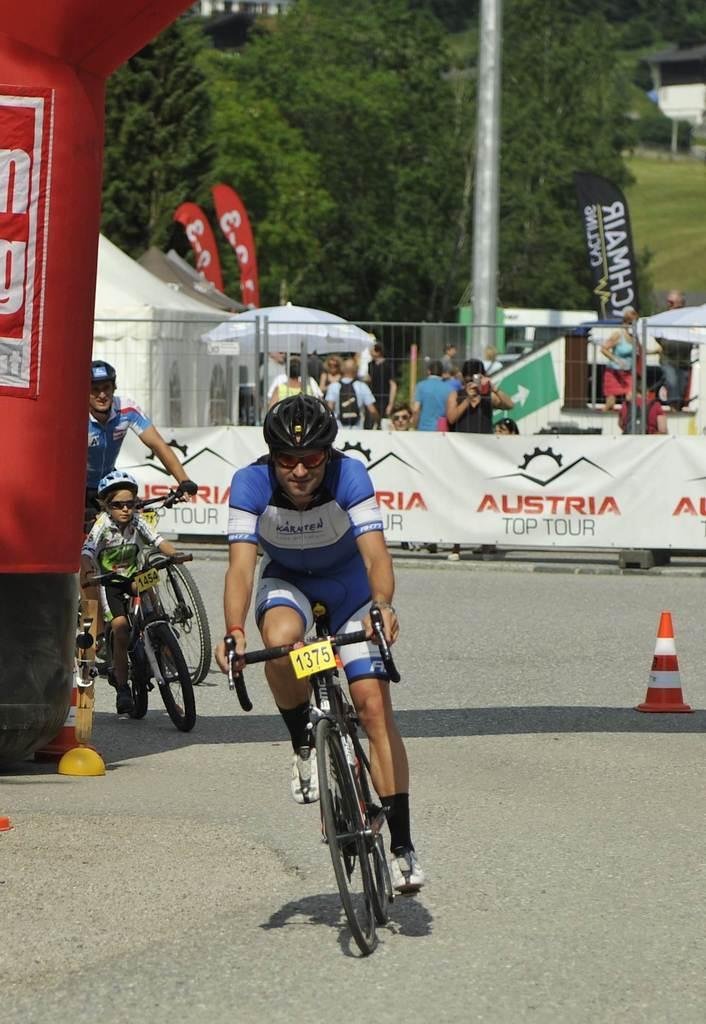Can you describe this image briefly? In this picture I can see three persons riding bicycles on the road, there are cone bar barricades, there are group of people standing, there are iron grilles, there are advertising flags, there are umbrellas, there is a canopy tent, and in the background there are trees. 